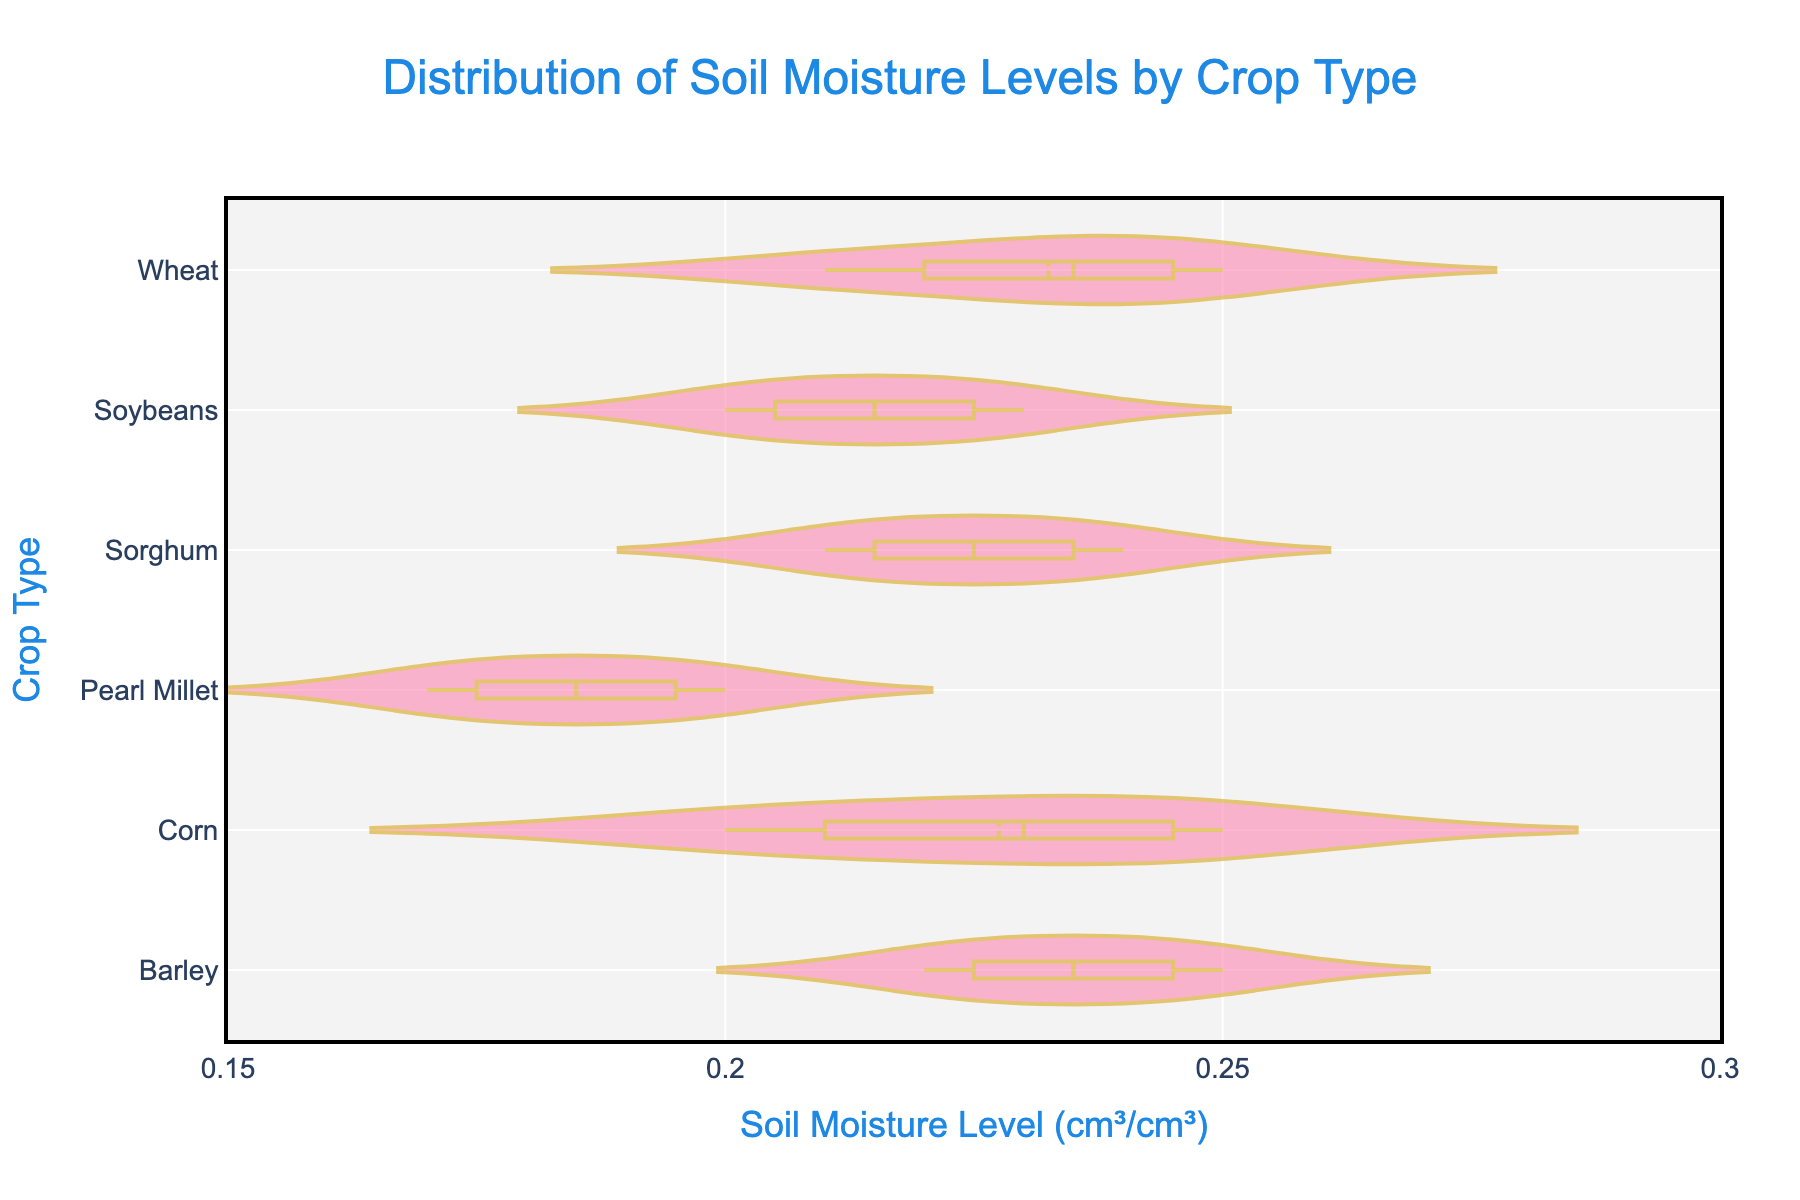What does the title of the plot say? The title is located at the top center of the plot. It reads "Distribution of Soil Moisture Levels by Crop Type".
Answer: "Distribution of Soil Moisture Levels by Crop Type" What crops have their soil moisture levels displayed in the plot? By looking at the different violin plots, we can see that the crops displayed are Wheat, Corn, Soybeans, Barley, Pearl Millet, and Sorghum.
Answer: Wheat, Corn, Soybeans, Barley, Pearl Millet, Sorghum Which crop has the highest average soil moisture level? Each crop's violin plot has a mean line. By comparing these lines, Barley appears to have the highest average soil moisture level.
Answer: Barley What is the range of soil moisture levels for Wheat? By observing the box and whiskers on the Wheat violin plot, you can determine the minimum and maximum values. The range extends approximately from 0.21 to 0.25 cm³/cm³.
Answer: 0.21 to 0.25 cm³/cm³ What is the median soil moisture level for Corn and how does it compare to that of Soybeans? The Corn and Soybeans violin plots have median lines. Corn's median is around 0.23 cm³/cm³ and Soybeans' median is around 0.215 cm³/cm³. Thus, Corn's median soil moisture level is higher than that of Soybeans.
Answer: Corn: 0.23 cm³/cm³, Soybeans: 0.215 cm³/cm³; Corn is higher Which crop showed the lowest variability in soil moisture levels? Variability can be assessed by the width and spread of the violin plots. Pearl Millet's plot is narrower and less spread out, indicating the lowest variability.
Answer: Pearl Millet How does Barley's soil moisture distribution compare to Pearl Millet's? Barley's violin plot is more spread out and has a wider range, indicating more variability compared to Pearl Millet, which shows a narrow and closely packed distribution.
Answer: Barley has higher variability Which crop type shows an increasing trend in soil moisture levels from May to August? By observing the months and soil moisture levels in the violin plots for each crop, Corn shows an increasing trend during this period.
Answer: Corn What does the color and opacity signify in these violin plots? The colors used in the plots are primarily for distinguishing different crops, and the opacity settings make sure multiple plots can be superimposed without losing visibility of underlying plots.
Answer: Distinguishing crops and maintaining visibility Which crop experiences the highest soil moisture level in the driest month? By referring to the lowest moisture levels displayed, we need to cross-check with the month information, specifically focusing on the crops showing the lowest line in their violin plot. Pearl Millet shows the lowest levels overall.
Answer: Pearl Millet 